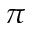Convert formula to latex. <formula><loc_0><loc_0><loc_500><loc_500>\pi</formula> 